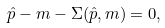Convert formula to latex. <formula><loc_0><loc_0><loc_500><loc_500>\hat { p } - m - \Sigma ( \hat { p } , m ) = 0 ,</formula> 